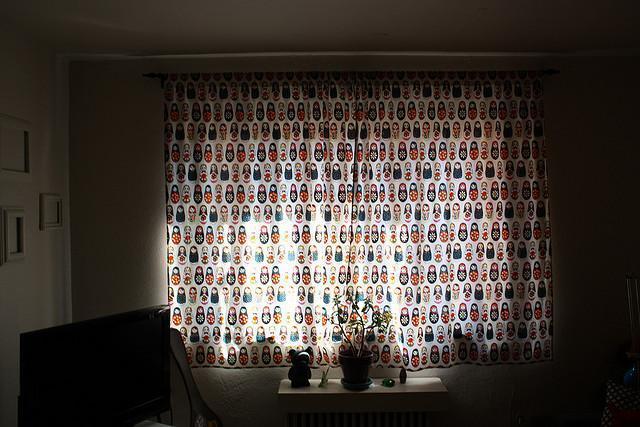How many tvs can be seen?
Give a very brief answer. 1. 